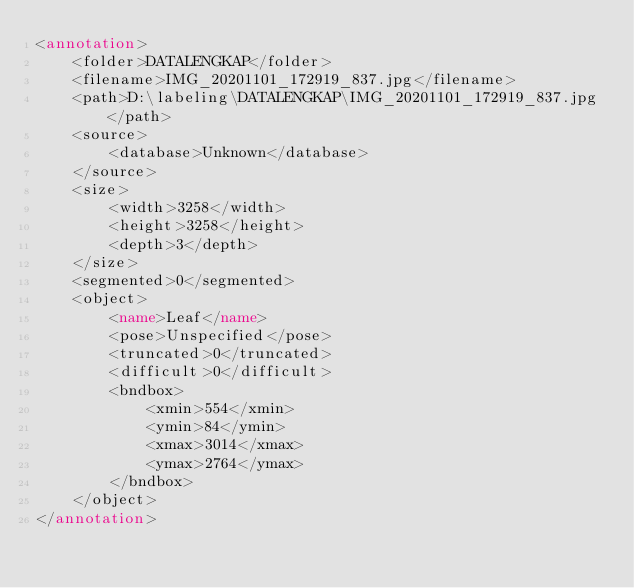<code> <loc_0><loc_0><loc_500><loc_500><_XML_><annotation>
	<folder>DATALENGKAP</folder>
	<filename>IMG_20201101_172919_837.jpg</filename>
	<path>D:\labeling\DATALENGKAP\IMG_20201101_172919_837.jpg</path>
	<source>
		<database>Unknown</database>
	</source>
	<size>
		<width>3258</width>
		<height>3258</height>
		<depth>3</depth>
	</size>
	<segmented>0</segmented>
	<object>
		<name>Leaf</name>
		<pose>Unspecified</pose>
		<truncated>0</truncated>
		<difficult>0</difficult>
		<bndbox>
			<xmin>554</xmin>
			<ymin>84</ymin>
			<xmax>3014</xmax>
			<ymax>2764</ymax>
		</bndbox>
	</object>
</annotation>
</code> 